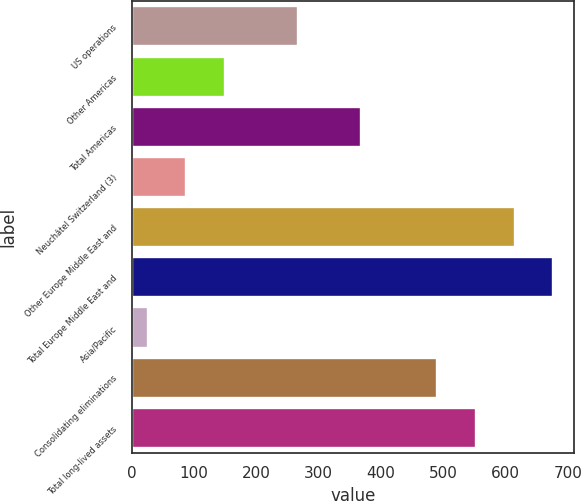Convert chart to OTSL. <chart><loc_0><loc_0><loc_500><loc_500><bar_chart><fcel>US operations<fcel>Other Americas<fcel>Total Americas<fcel>Neuchâtel Switzerland (3)<fcel>Other Europe Middle East and<fcel>Total Europe Middle East and<fcel>Asia/Pacific<fcel>Consolidating eliminations<fcel>Total long-lived assets<nl><fcel>266.4<fcel>149.12<fcel>368.5<fcel>87.16<fcel>614.42<fcel>676.38<fcel>25.2<fcel>490.5<fcel>552.46<nl></chart> 